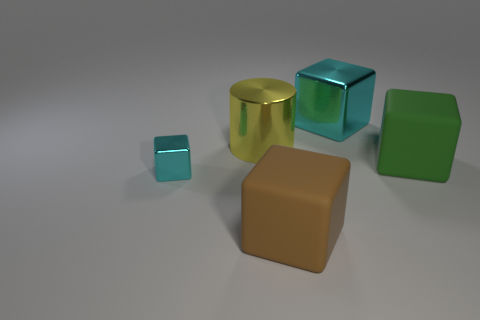Subtract all large cubes. How many cubes are left? 1 Add 5 cyan metal cubes. How many objects exist? 10 Subtract all blocks. How many objects are left? 1 Subtract all blue cubes. Subtract all red cylinders. How many cubes are left? 4 Subtract all big yellow cylinders. Subtract all brown things. How many objects are left? 3 Add 2 large brown cubes. How many large brown cubes are left? 3 Add 2 big brown rubber objects. How many big brown rubber objects exist? 3 Subtract 0 purple balls. How many objects are left? 5 